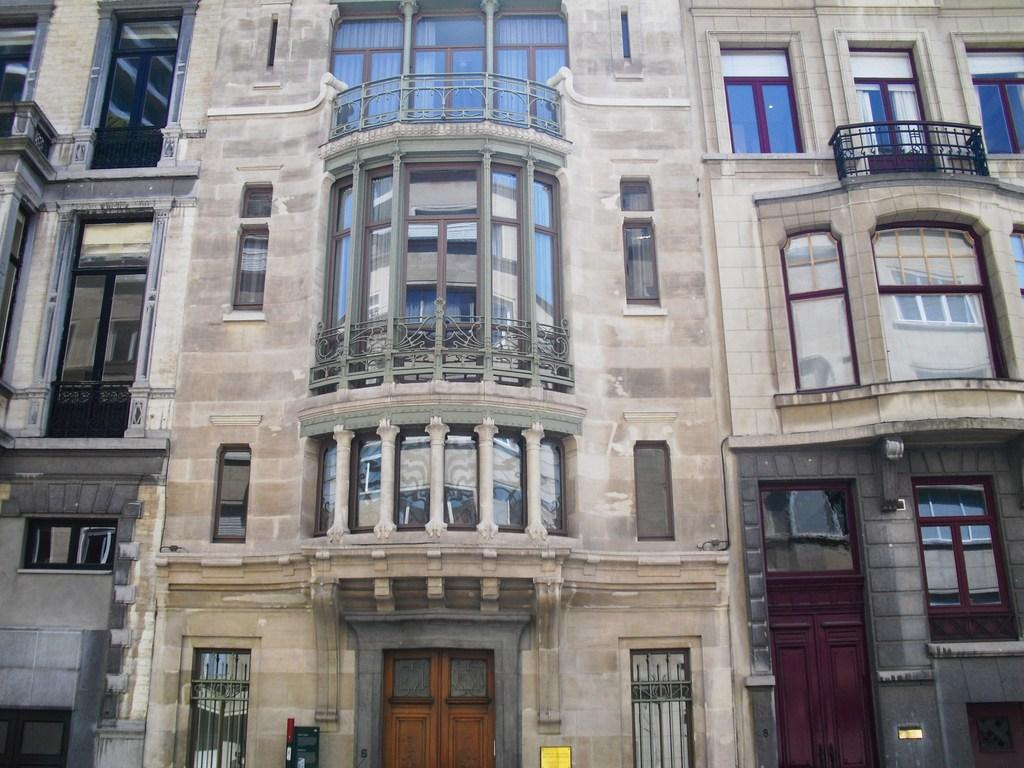What type of structure is in the image? There is a building in the image. What features can be seen on the building? The building has windows and doors. What safety feature is present in the image? Railings are present in the image. What material is visible in the image? Boards are visible in the image. What type of sack is being used to extinguish the fire in the image? There is no fire or sack present in the image. What thrilling activity is taking place in the image? There is no thrilling activity depicted in the image; it features a building with windows, doors, railings, and boards. 